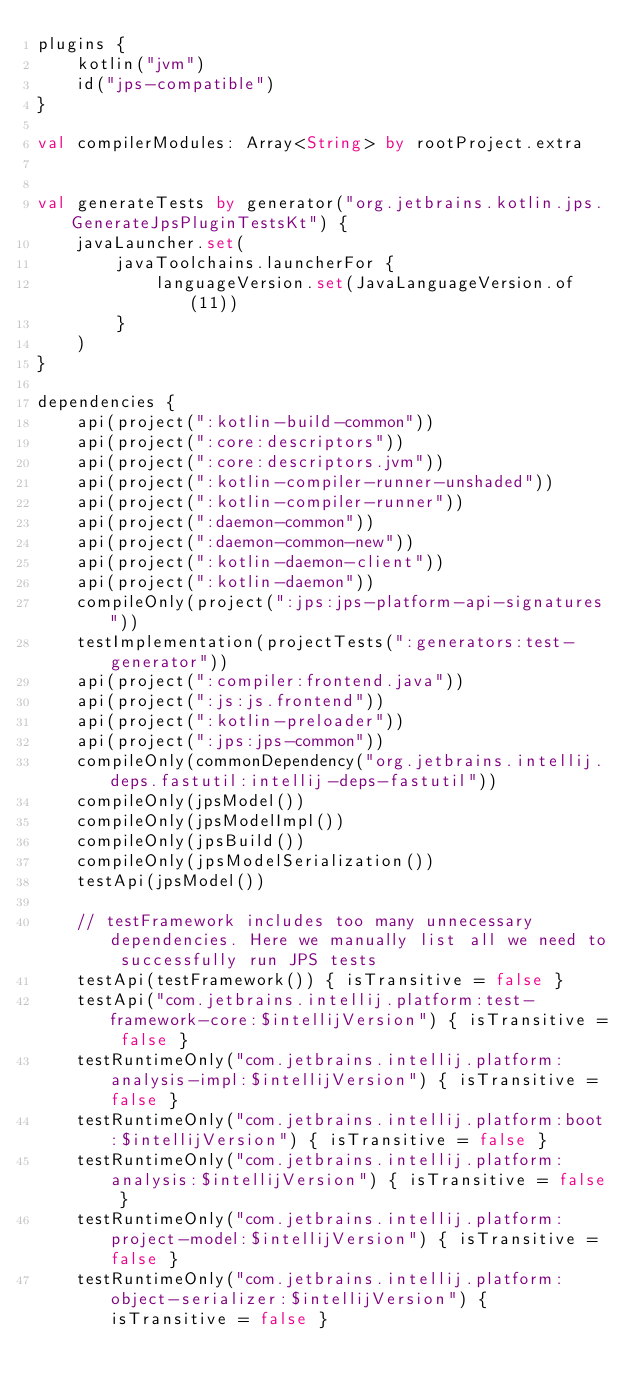<code> <loc_0><loc_0><loc_500><loc_500><_Kotlin_>plugins {
    kotlin("jvm")
    id("jps-compatible")
}

val compilerModules: Array<String> by rootProject.extra


val generateTests by generator("org.jetbrains.kotlin.jps.GenerateJpsPluginTestsKt") {
    javaLauncher.set(
        javaToolchains.launcherFor {
            languageVersion.set(JavaLanguageVersion.of(11))
        }
    )
}

dependencies {
    api(project(":kotlin-build-common"))
    api(project(":core:descriptors"))
    api(project(":core:descriptors.jvm"))
    api(project(":kotlin-compiler-runner-unshaded"))
    api(project(":kotlin-compiler-runner"))
    api(project(":daemon-common"))
    api(project(":daemon-common-new"))
    api(project(":kotlin-daemon-client"))
    api(project(":kotlin-daemon"))
    compileOnly(project(":jps:jps-platform-api-signatures"))
    testImplementation(projectTests(":generators:test-generator"))
    api(project(":compiler:frontend.java"))
    api(project(":js:js.frontend"))
    api(project(":kotlin-preloader"))
    api(project(":jps:jps-common"))
    compileOnly(commonDependency("org.jetbrains.intellij.deps.fastutil:intellij-deps-fastutil"))
    compileOnly(jpsModel())
    compileOnly(jpsModelImpl())
    compileOnly(jpsBuild())
    compileOnly(jpsModelSerialization())
    testApi(jpsModel())

    // testFramework includes too many unnecessary dependencies. Here we manually list all we need to successfully run JPS tests
    testApi(testFramework()) { isTransitive = false }
    testApi("com.jetbrains.intellij.platform:test-framework-core:$intellijVersion") { isTransitive = false }
    testRuntimeOnly("com.jetbrains.intellij.platform:analysis-impl:$intellijVersion") { isTransitive = false }
    testRuntimeOnly("com.jetbrains.intellij.platform:boot:$intellijVersion") { isTransitive = false }
    testRuntimeOnly("com.jetbrains.intellij.platform:analysis:$intellijVersion") { isTransitive = false }
    testRuntimeOnly("com.jetbrains.intellij.platform:project-model:$intellijVersion") { isTransitive = false }
    testRuntimeOnly("com.jetbrains.intellij.platform:object-serializer:$intellijVersion") { isTransitive = false }</code> 